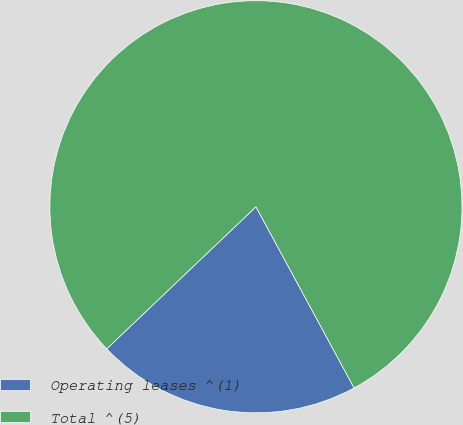Convert chart. <chart><loc_0><loc_0><loc_500><loc_500><pie_chart><fcel>Operating leases ^(1)<fcel>Total ^(5)<nl><fcel>20.79%<fcel>79.21%<nl></chart> 